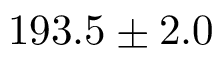<formula> <loc_0><loc_0><loc_500><loc_500>1 9 3 . 5 \pm 2 . 0</formula> 